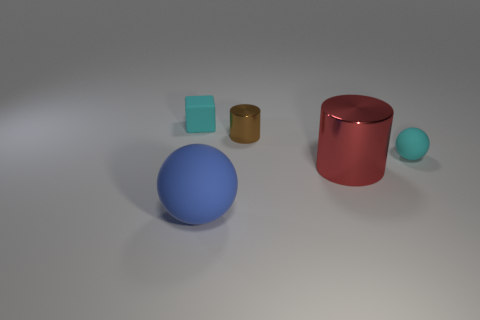Add 3 big red metal things. How many objects exist? 8 Subtract all spheres. How many objects are left? 3 Add 1 large red metal spheres. How many large red metal spheres exist? 1 Subtract 0 brown cubes. How many objects are left? 5 Subtract all tiny cyan objects. Subtract all large cylinders. How many objects are left? 2 Add 4 small cyan balls. How many small cyan balls are left? 5 